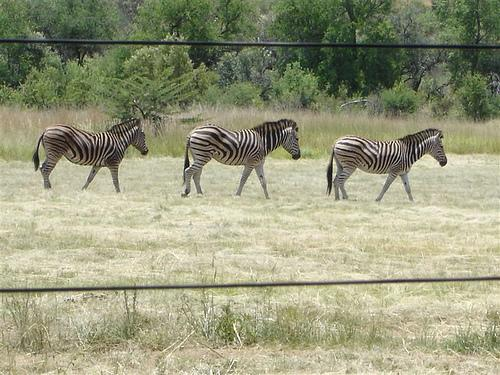How many zebra are walking in a line behind the fence?

Choices:
A) two
B) four
C) three
D) one three 